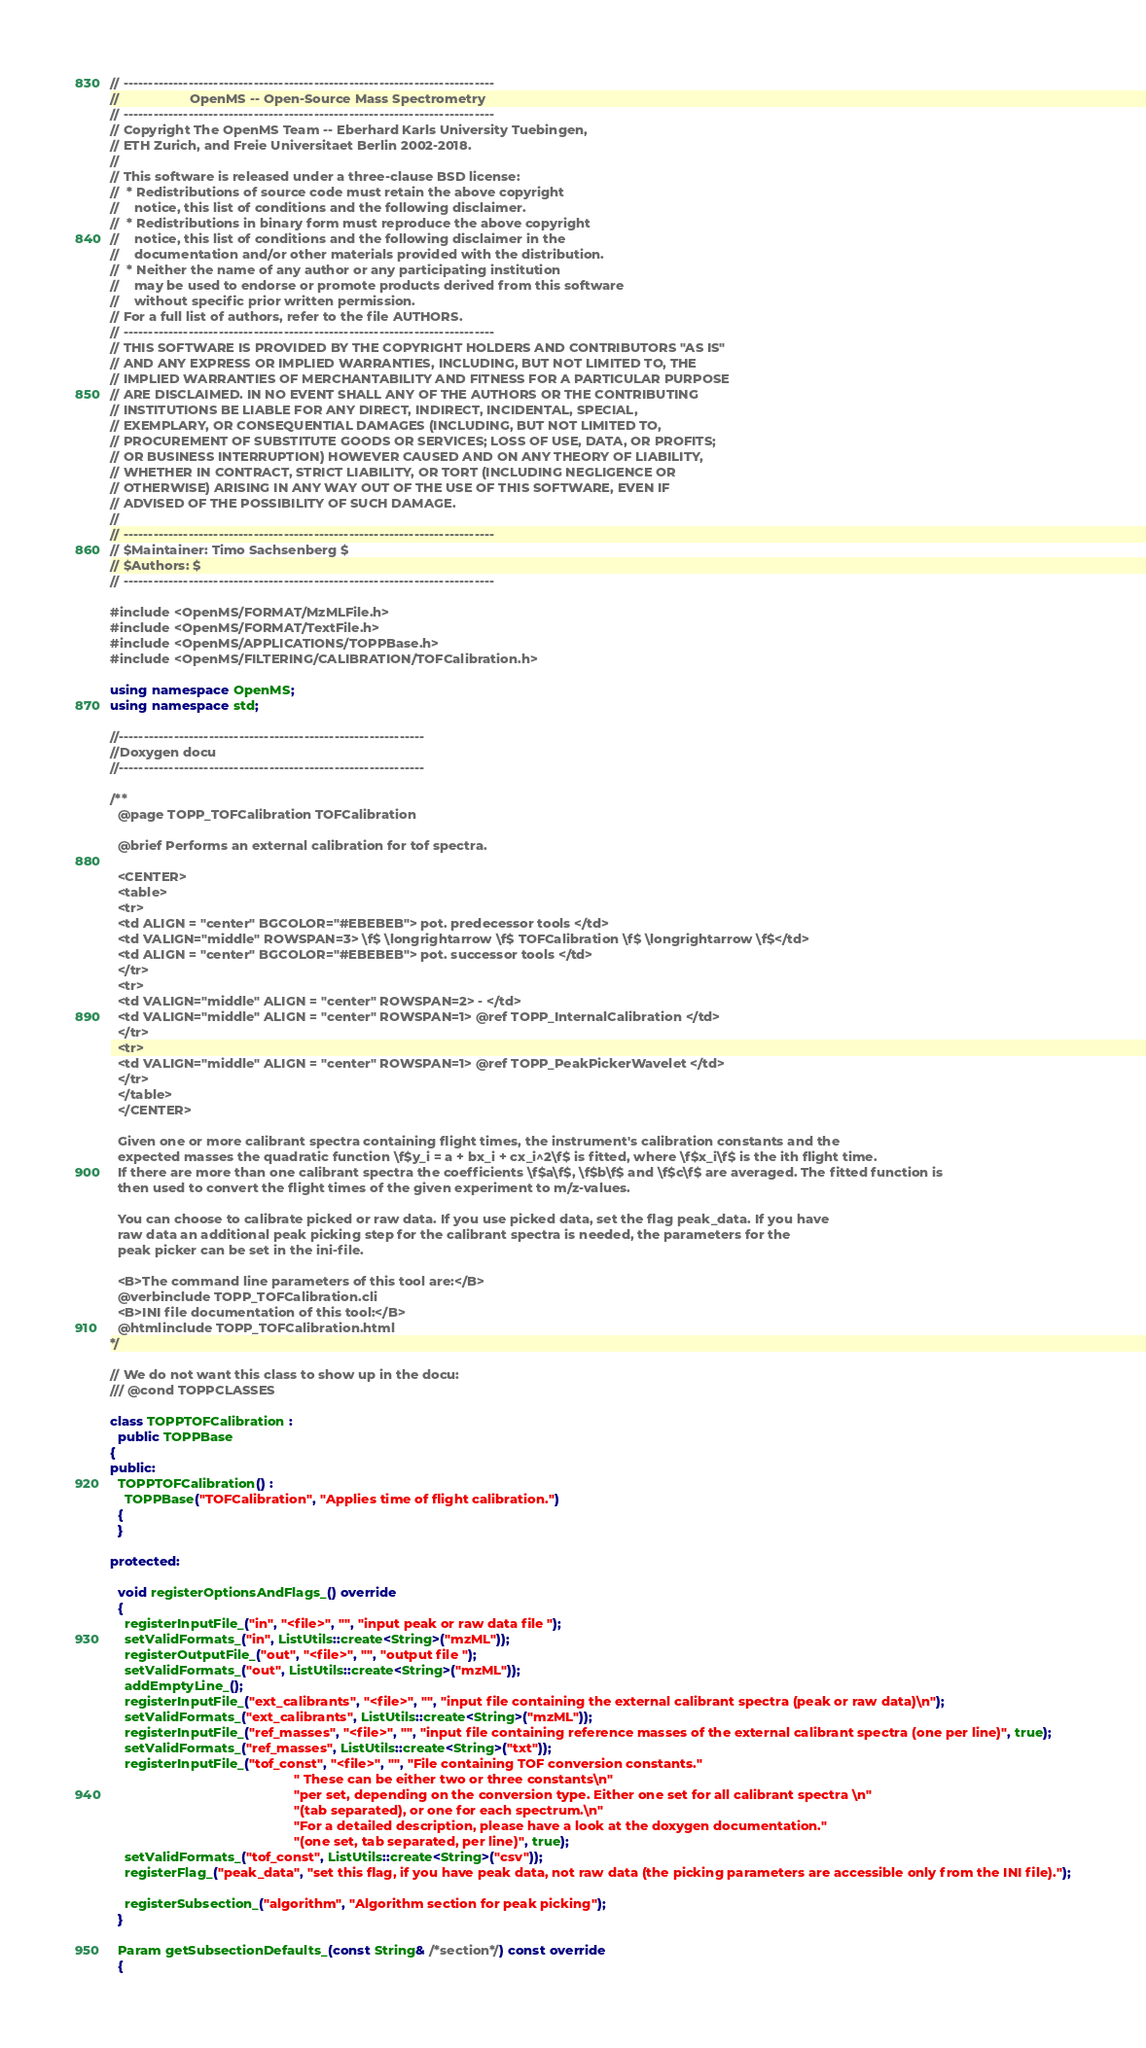<code> <loc_0><loc_0><loc_500><loc_500><_C++_>// --------------------------------------------------------------------------
//                   OpenMS -- Open-Source Mass Spectrometry
// --------------------------------------------------------------------------
// Copyright The OpenMS Team -- Eberhard Karls University Tuebingen,
// ETH Zurich, and Freie Universitaet Berlin 2002-2018.
//
// This software is released under a three-clause BSD license:
//  * Redistributions of source code must retain the above copyright
//    notice, this list of conditions and the following disclaimer.
//  * Redistributions in binary form must reproduce the above copyright
//    notice, this list of conditions and the following disclaimer in the
//    documentation and/or other materials provided with the distribution.
//  * Neither the name of any author or any participating institution
//    may be used to endorse or promote products derived from this software
//    without specific prior written permission.
// For a full list of authors, refer to the file AUTHORS.
// --------------------------------------------------------------------------
// THIS SOFTWARE IS PROVIDED BY THE COPYRIGHT HOLDERS AND CONTRIBUTORS "AS IS"
// AND ANY EXPRESS OR IMPLIED WARRANTIES, INCLUDING, BUT NOT LIMITED TO, THE
// IMPLIED WARRANTIES OF MERCHANTABILITY AND FITNESS FOR A PARTICULAR PURPOSE
// ARE DISCLAIMED. IN NO EVENT SHALL ANY OF THE AUTHORS OR THE CONTRIBUTING
// INSTITUTIONS BE LIABLE FOR ANY DIRECT, INDIRECT, INCIDENTAL, SPECIAL,
// EXEMPLARY, OR CONSEQUENTIAL DAMAGES (INCLUDING, BUT NOT LIMITED TO,
// PROCUREMENT OF SUBSTITUTE GOODS OR SERVICES; LOSS OF USE, DATA, OR PROFITS;
// OR BUSINESS INTERRUPTION) HOWEVER CAUSED AND ON ANY THEORY OF LIABILITY,
// WHETHER IN CONTRACT, STRICT LIABILITY, OR TORT (INCLUDING NEGLIGENCE OR
// OTHERWISE) ARISING IN ANY WAY OUT OF THE USE OF THIS SOFTWARE, EVEN IF
// ADVISED OF THE POSSIBILITY OF SUCH DAMAGE.
//
// --------------------------------------------------------------------------
// $Maintainer: Timo Sachsenberg $
// $Authors: $
// --------------------------------------------------------------------------

#include <OpenMS/FORMAT/MzMLFile.h>
#include <OpenMS/FORMAT/TextFile.h>
#include <OpenMS/APPLICATIONS/TOPPBase.h>
#include <OpenMS/FILTERING/CALIBRATION/TOFCalibration.h>

using namespace OpenMS;
using namespace std;

//-------------------------------------------------------------
//Doxygen docu
//-------------------------------------------------------------

/**
  @page TOPP_TOFCalibration TOFCalibration

  @brief Performs an external calibration for tof spectra.

  <CENTER>
  <table>
  <tr>
  <td ALIGN = "center" BGCOLOR="#EBEBEB"> pot. predecessor tools </td>
  <td VALIGN="middle" ROWSPAN=3> \f$ \longrightarrow \f$ TOFCalibration \f$ \longrightarrow \f$</td>
  <td ALIGN = "center" BGCOLOR="#EBEBEB"> pot. successor tools </td>
  </tr>
  <tr>
  <td VALIGN="middle" ALIGN = "center" ROWSPAN=2> - </td>
  <td VALIGN="middle" ALIGN = "center" ROWSPAN=1> @ref TOPP_InternalCalibration </td>
  </tr>
  <tr>
  <td VALIGN="middle" ALIGN = "center" ROWSPAN=1> @ref TOPP_PeakPickerWavelet </td>
  </tr>
  </table>
  </CENTER>

  Given one or more calibrant spectra containing flight times, the instrument's calibration constants and the
  expected masses the quadratic function \f$y_i = a + bx_i + cx_i^2\f$ is fitted, where \f$x_i\f$ is the ith flight time.
  If there are more than one calibrant spectra the coefficients \f$a\f$, \f$b\f$ and \f$c\f$ are averaged. The fitted function is
  then used to convert the flight times of the given experiment to m/z-values.

  You can choose to calibrate picked or raw data. If you use picked data, set the flag peak_data. If you have
  raw data an additional peak picking step for the calibrant spectra is needed, the parameters for the
  peak picker can be set in the ini-file.

  <B>The command line parameters of this tool are:</B>
  @verbinclude TOPP_TOFCalibration.cli
  <B>INI file documentation of this tool:</B>
  @htmlinclude TOPP_TOFCalibration.html
*/

// We do not want this class to show up in the docu:
/// @cond TOPPCLASSES

class TOPPTOFCalibration :
  public TOPPBase
{
public:
  TOPPTOFCalibration() :
    TOPPBase("TOFCalibration", "Applies time of flight calibration.")
  {
  }

protected:

  void registerOptionsAndFlags_() override
  {
    registerInputFile_("in", "<file>", "", "input peak or raw data file ");
    setValidFormats_("in", ListUtils::create<String>("mzML"));
    registerOutputFile_("out", "<file>", "", "output file ");
    setValidFormats_("out", ListUtils::create<String>("mzML"));
    addEmptyLine_();
    registerInputFile_("ext_calibrants", "<file>", "", "input file containing the external calibrant spectra (peak or raw data)\n");
    setValidFormats_("ext_calibrants", ListUtils::create<String>("mzML"));
    registerInputFile_("ref_masses", "<file>", "", "input file containing reference masses of the external calibrant spectra (one per line)", true);
    setValidFormats_("ref_masses", ListUtils::create<String>("txt"));
    registerInputFile_("tof_const", "<file>", "", "File containing TOF conversion constants."
                                                  " These can be either two or three constants\n"
                                                  "per set, depending on the conversion type. Either one set for all calibrant spectra \n"
                                                  "(tab separated), or one for each spectrum.\n"
                                                  "For a detailed description, please have a look at the doxygen documentation."
                                                  "(one set, tab separated, per line)", true);
    setValidFormats_("tof_const", ListUtils::create<String>("csv"));
    registerFlag_("peak_data", "set this flag, if you have peak data, not raw data (the picking parameters are accessible only from the INI file).");

    registerSubsection_("algorithm", "Algorithm section for peak picking");
  }

  Param getSubsectionDefaults_(const String& /*section*/) const override
  {</code> 